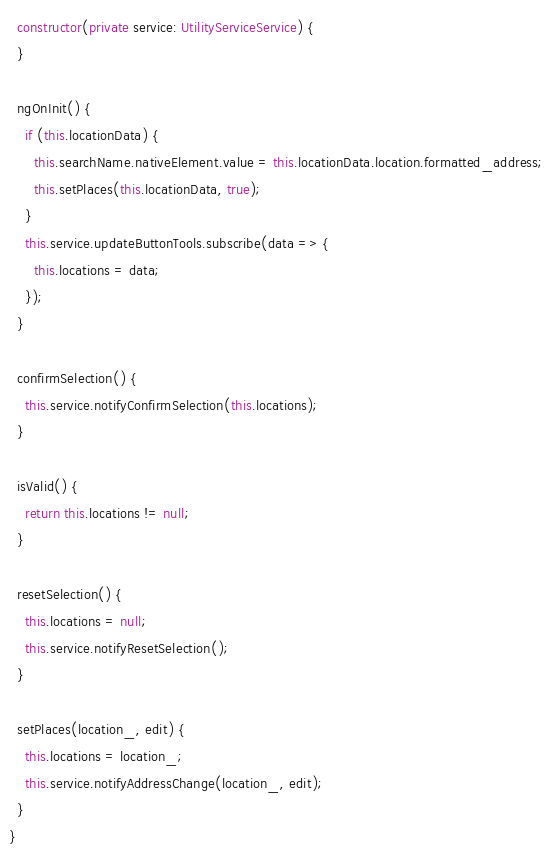<code> <loc_0><loc_0><loc_500><loc_500><_TypeScript_>
  constructor(private service: UtilityServiceService) {
  }

  ngOnInit() {
    if (this.locationData) {
      this.searchName.nativeElement.value = this.locationData.location.formatted_address;
      this.setPlaces(this.locationData, true);
    }
    this.service.updateButtonTools.subscribe(data => {
      this.locations = data;
    });
  }

  confirmSelection() {
    this.service.notifyConfirmSelection(this.locations);
  }

  isValid() {
    return this.locations != null;
  }

  resetSelection() {
    this.locations = null;
    this.service.notifyResetSelection();
  }

  setPlaces(location_, edit) {
    this.locations = location_;
    this.service.notifyAddressChange(location_, edit);
  }
}
</code> 